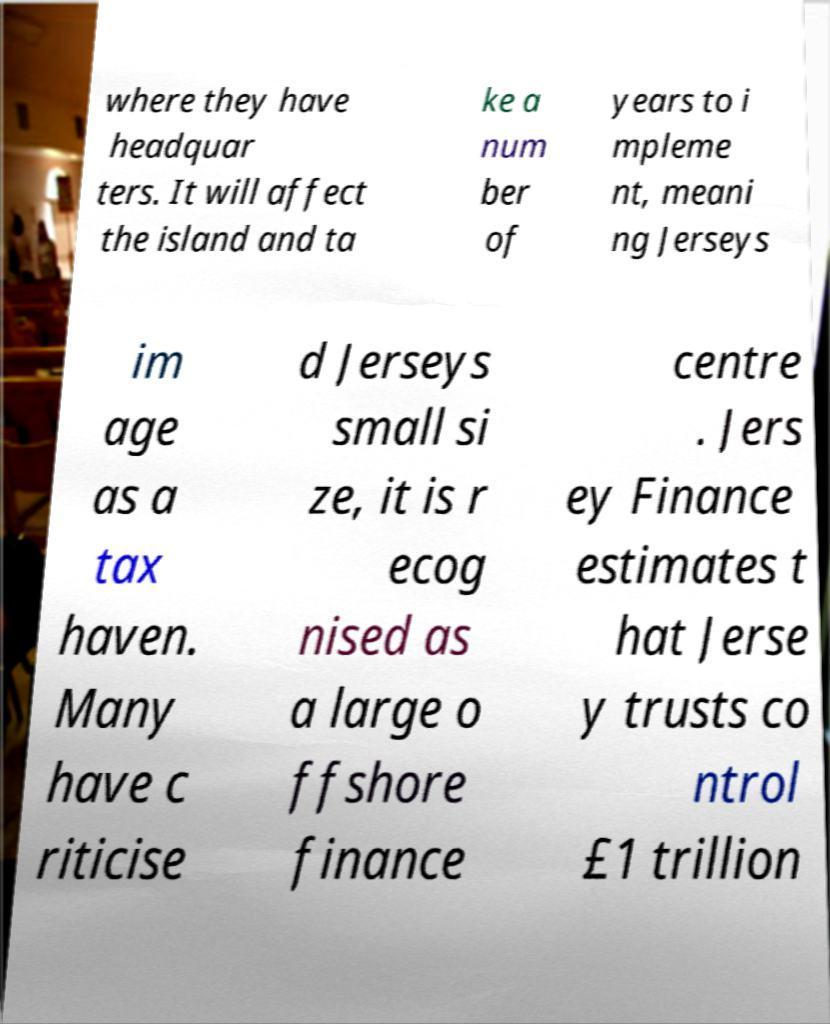I need the written content from this picture converted into text. Can you do that? where they have headquar ters. It will affect the island and ta ke a num ber of years to i mpleme nt, meani ng Jerseys im age as a tax haven. Many have c riticise d Jerseys small si ze, it is r ecog nised as a large o ffshore finance centre . Jers ey Finance estimates t hat Jerse y trusts co ntrol £1 trillion 